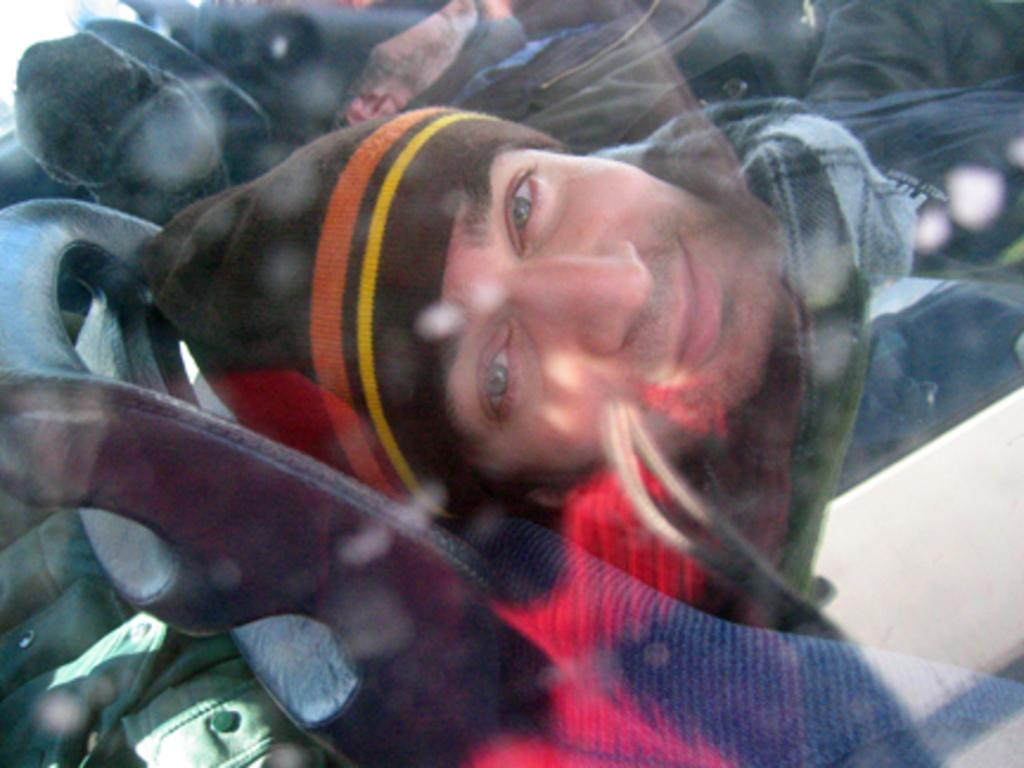Who is the main subject in the image? There is a man in the image. What is the man wearing? The man is wearing a jacket, scarf, and cap. What is the man doing in the image? The man is sitting in a chair. Can you describe the other person in the image? There is another person at the top of the image. What color is the jacket on the left side of the image? The jacket on the left side of the image is green. What type of honey is the man eating in the image? There is no honey present in the image, and the man is not eating anything. 